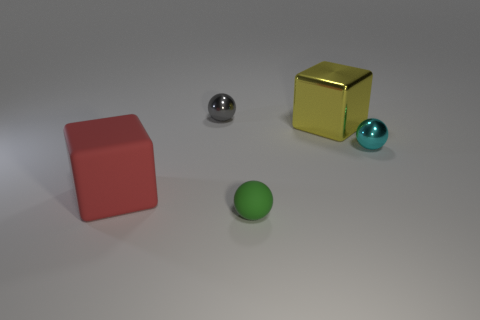If this image were part of a riddle involving the objects, what could the riddle be? Four companions am I to behold: two of round cheer, two squarely bold. One reflects gold, another, the sky; one with a sheen, one matte to the eye. What am I? Can you provide a hint to solve the riddle? The answer lies in observing their forms—both the sphere and cube are represented twice, differing only in their luster and hue, serving as clues to discerning each one's true. 